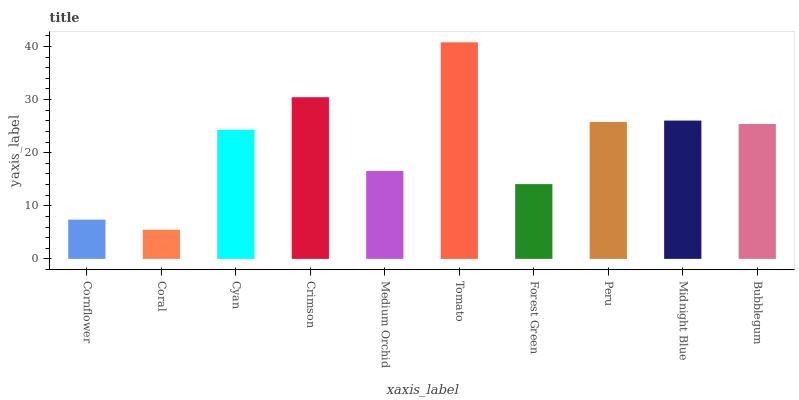Is Coral the minimum?
Answer yes or no. Yes. Is Tomato the maximum?
Answer yes or no. Yes. Is Cyan the minimum?
Answer yes or no. No. Is Cyan the maximum?
Answer yes or no. No. Is Cyan greater than Coral?
Answer yes or no. Yes. Is Coral less than Cyan?
Answer yes or no. Yes. Is Coral greater than Cyan?
Answer yes or no. No. Is Cyan less than Coral?
Answer yes or no. No. Is Bubblegum the high median?
Answer yes or no. Yes. Is Cyan the low median?
Answer yes or no. Yes. Is Crimson the high median?
Answer yes or no. No. Is Forest Green the low median?
Answer yes or no. No. 